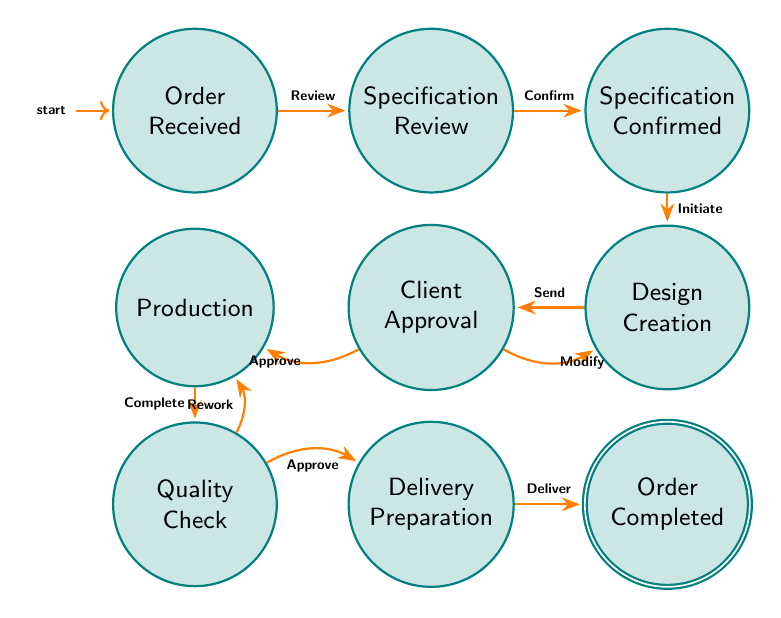What is the starting state in the order processing? The starting state is typically where the process begins, which is "Order Received."
Answer: Order Received How many states are there in total in this diagram? By counting the different labels representing states, there are a total of nine states.
Answer: Nine Which state follows "Specification Review"? By following the arrow leading from "Specification Review," the next state is "Specification Confirmed."
Answer: Specification Confirmed What action is taken when moving from "Client Approval" to "Production"? The transition from "Client Approval" to "Production" involves the action of approving the design for production.
Answer: Approve Design for Production What condition leads to moving back to "Design Creation" from "Client Approval"? The transition back to "Design Creation," if the design is rejected, is specifically due to feedback that necessitates modifications.
Answer: Design Rejected In how many different ways can the process transition from "Quality Check"? There are two possible transitions from "Quality Check": one goes to "Delivery Preparation," and the other goes back to "Production" if there are quality issues.
Answer: Two What is the final state that indicates the order has been completed? The final state that signifies the completion of the order process is "Order Completed."
Answer: Order Completed What occurs after "Production" in the order processing sequence? After "Production," the next state where the materials are checked is "Quality Check."
Answer: Quality Check What happens in the "Delivery Preparation" state? In the "Delivery Preparation" state, the event materials are prepared for delivery to the client.
Answer: Deliver event materials 